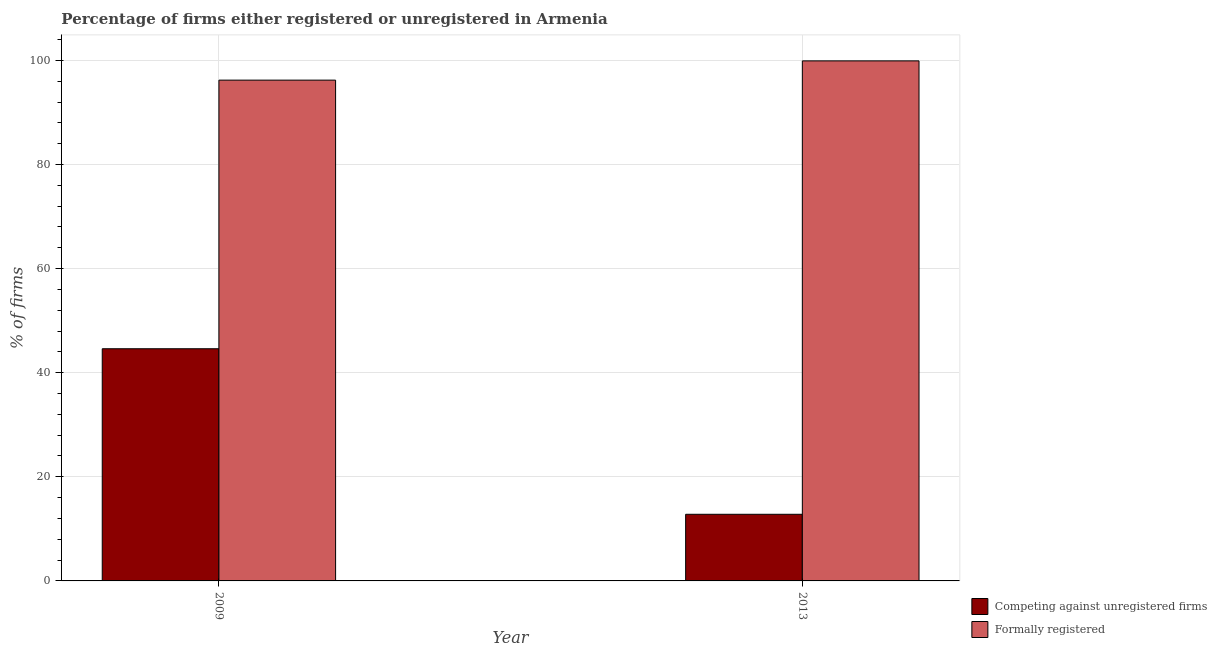How many different coloured bars are there?
Make the answer very short. 2. Are the number of bars per tick equal to the number of legend labels?
Your answer should be compact. Yes. Are the number of bars on each tick of the X-axis equal?
Keep it short and to the point. Yes. What is the label of the 1st group of bars from the left?
Provide a succinct answer. 2009. In how many cases, is the number of bars for a given year not equal to the number of legend labels?
Your response must be concise. 0. What is the percentage of registered firms in 2009?
Provide a succinct answer. 44.6. Across all years, what is the maximum percentage of registered firms?
Your answer should be compact. 44.6. In which year was the percentage of registered firms minimum?
Your response must be concise. 2013. What is the total percentage of formally registered firms in the graph?
Provide a succinct answer. 196.1. What is the difference between the percentage of registered firms in 2009 and that in 2013?
Provide a short and direct response. 31.8. What is the difference between the percentage of formally registered firms in 2009 and the percentage of registered firms in 2013?
Make the answer very short. -3.7. What is the average percentage of registered firms per year?
Make the answer very short. 28.7. What is the ratio of the percentage of formally registered firms in 2009 to that in 2013?
Give a very brief answer. 0.96. In how many years, is the percentage of registered firms greater than the average percentage of registered firms taken over all years?
Offer a very short reply. 1. What does the 1st bar from the left in 2009 represents?
Your answer should be compact. Competing against unregistered firms. What does the 1st bar from the right in 2013 represents?
Provide a short and direct response. Formally registered. How many bars are there?
Provide a succinct answer. 4. Are all the bars in the graph horizontal?
Make the answer very short. No. Where does the legend appear in the graph?
Your answer should be compact. Bottom right. How many legend labels are there?
Give a very brief answer. 2. What is the title of the graph?
Offer a very short reply. Percentage of firms either registered or unregistered in Armenia. Does "Lower secondary rate" appear as one of the legend labels in the graph?
Provide a succinct answer. No. What is the label or title of the Y-axis?
Offer a terse response. % of firms. What is the % of firms of Competing against unregistered firms in 2009?
Offer a terse response. 44.6. What is the % of firms in Formally registered in 2009?
Your answer should be compact. 96.2. What is the % of firms of Formally registered in 2013?
Your answer should be compact. 99.9. Across all years, what is the maximum % of firms in Competing against unregistered firms?
Give a very brief answer. 44.6. Across all years, what is the maximum % of firms in Formally registered?
Keep it short and to the point. 99.9. Across all years, what is the minimum % of firms of Competing against unregistered firms?
Your response must be concise. 12.8. Across all years, what is the minimum % of firms in Formally registered?
Your response must be concise. 96.2. What is the total % of firms in Competing against unregistered firms in the graph?
Offer a terse response. 57.4. What is the total % of firms in Formally registered in the graph?
Offer a very short reply. 196.1. What is the difference between the % of firms in Competing against unregistered firms in 2009 and that in 2013?
Keep it short and to the point. 31.8. What is the difference between the % of firms of Formally registered in 2009 and that in 2013?
Make the answer very short. -3.7. What is the difference between the % of firms of Competing against unregistered firms in 2009 and the % of firms of Formally registered in 2013?
Offer a very short reply. -55.3. What is the average % of firms in Competing against unregistered firms per year?
Give a very brief answer. 28.7. What is the average % of firms of Formally registered per year?
Your answer should be compact. 98.05. In the year 2009, what is the difference between the % of firms of Competing against unregistered firms and % of firms of Formally registered?
Your answer should be compact. -51.6. In the year 2013, what is the difference between the % of firms of Competing against unregistered firms and % of firms of Formally registered?
Offer a terse response. -87.1. What is the ratio of the % of firms of Competing against unregistered firms in 2009 to that in 2013?
Keep it short and to the point. 3.48. What is the difference between the highest and the second highest % of firms in Competing against unregistered firms?
Offer a very short reply. 31.8. What is the difference between the highest and the lowest % of firms of Competing against unregistered firms?
Offer a terse response. 31.8. What is the difference between the highest and the lowest % of firms in Formally registered?
Ensure brevity in your answer.  3.7. 